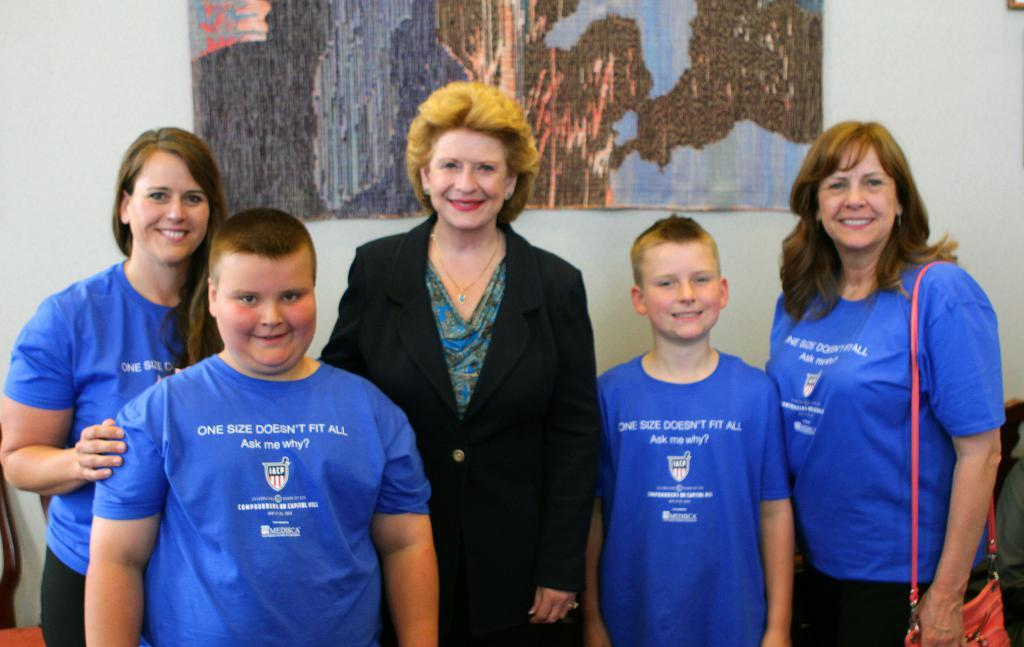<image>
Write a terse but informative summary of the picture. Four people wearing shirts that say "One size doesn't fit all. Ask me why?" stand with a woman in a suit. 